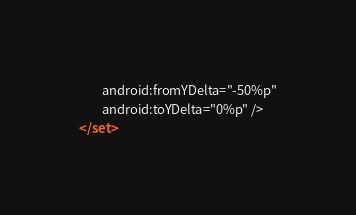<code> <loc_0><loc_0><loc_500><loc_500><_XML_>        android:fromYDelta="-50%p"
        android:toYDelta="0%p" />
</set></code> 